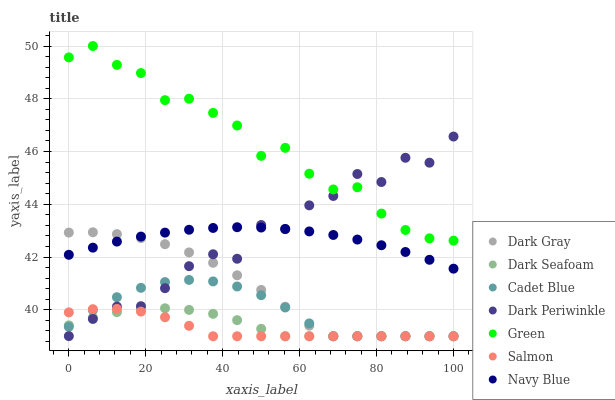Does Salmon have the minimum area under the curve?
Answer yes or no. Yes. Does Green have the maximum area under the curve?
Answer yes or no. Yes. Does Navy Blue have the minimum area under the curve?
Answer yes or no. No. Does Navy Blue have the maximum area under the curve?
Answer yes or no. No. Is Navy Blue the smoothest?
Answer yes or no. Yes. Is Dark Periwinkle the roughest?
Answer yes or no. Yes. Is Salmon the smoothest?
Answer yes or no. No. Is Salmon the roughest?
Answer yes or no. No. Does Cadet Blue have the lowest value?
Answer yes or no. Yes. Does Navy Blue have the lowest value?
Answer yes or no. No. Does Green have the highest value?
Answer yes or no. Yes. Does Navy Blue have the highest value?
Answer yes or no. No. Is Cadet Blue less than Navy Blue?
Answer yes or no. Yes. Is Green greater than Dark Gray?
Answer yes or no. Yes. Does Dark Periwinkle intersect Dark Gray?
Answer yes or no. Yes. Is Dark Periwinkle less than Dark Gray?
Answer yes or no. No. Is Dark Periwinkle greater than Dark Gray?
Answer yes or no. No. Does Cadet Blue intersect Navy Blue?
Answer yes or no. No. 